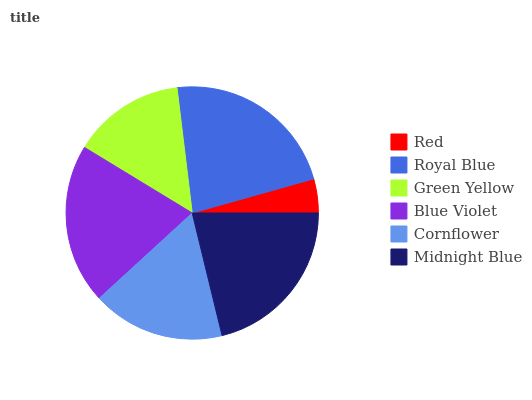Is Red the minimum?
Answer yes or no. Yes. Is Royal Blue the maximum?
Answer yes or no. Yes. Is Green Yellow the minimum?
Answer yes or no. No. Is Green Yellow the maximum?
Answer yes or no. No. Is Royal Blue greater than Green Yellow?
Answer yes or no. Yes. Is Green Yellow less than Royal Blue?
Answer yes or no. Yes. Is Green Yellow greater than Royal Blue?
Answer yes or no. No. Is Royal Blue less than Green Yellow?
Answer yes or no. No. Is Blue Violet the high median?
Answer yes or no. Yes. Is Cornflower the low median?
Answer yes or no. Yes. Is Green Yellow the high median?
Answer yes or no. No. Is Blue Violet the low median?
Answer yes or no. No. 